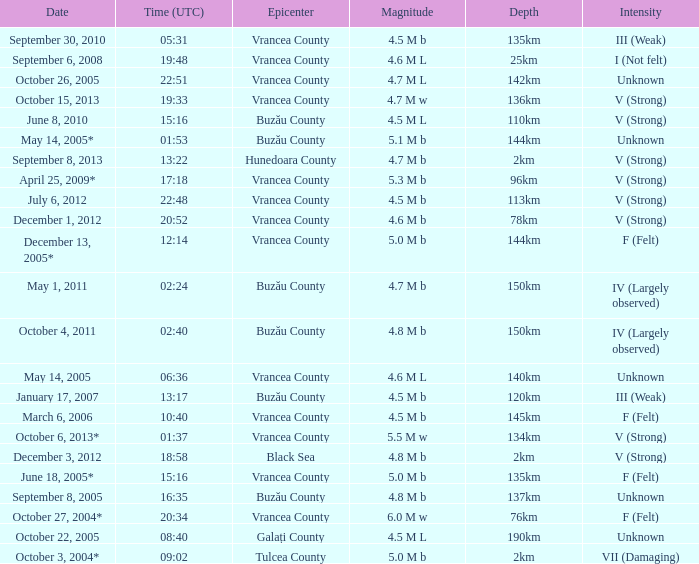What is the magnitude with epicenter at Vrancea County, unknown intensity and which happened at 06:36? 4.6 M L. 